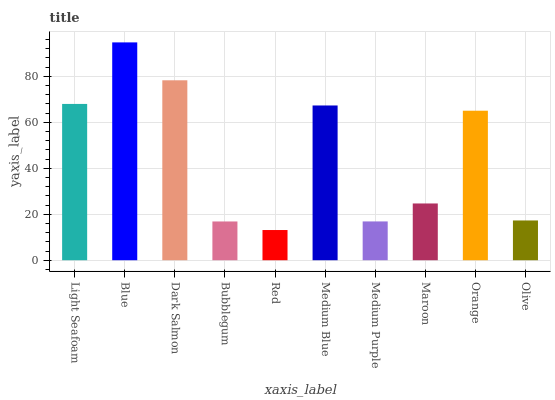Is Red the minimum?
Answer yes or no. Yes. Is Blue the maximum?
Answer yes or no. Yes. Is Dark Salmon the minimum?
Answer yes or no. No. Is Dark Salmon the maximum?
Answer yes or no. No. Is Blue greater than Dark Salmon?
Answer yes or no. Yes. Is Dark Salmon less than Blue?
Answer yes or no. Yes. Is Dark Salmon greater than Blue?
Answer yes or no. No. Is Blue less than Dark Salmon?
Answer yes or no. No. Is Orange the high median?
Answer yes or no. Yes. Is Maroon the low median?
Answer yes or no. Yes. Is Dark Salmon the high median?
Answer yes or no. No. Is Orange the low median?
Answer yes or no. No. 